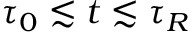Convert formula to latex. <formula><loc_0><loc_0><loc_500><loc_500>\tau _ { 0 } \lesssim t \lesssim \tau _ { R }</formula> 